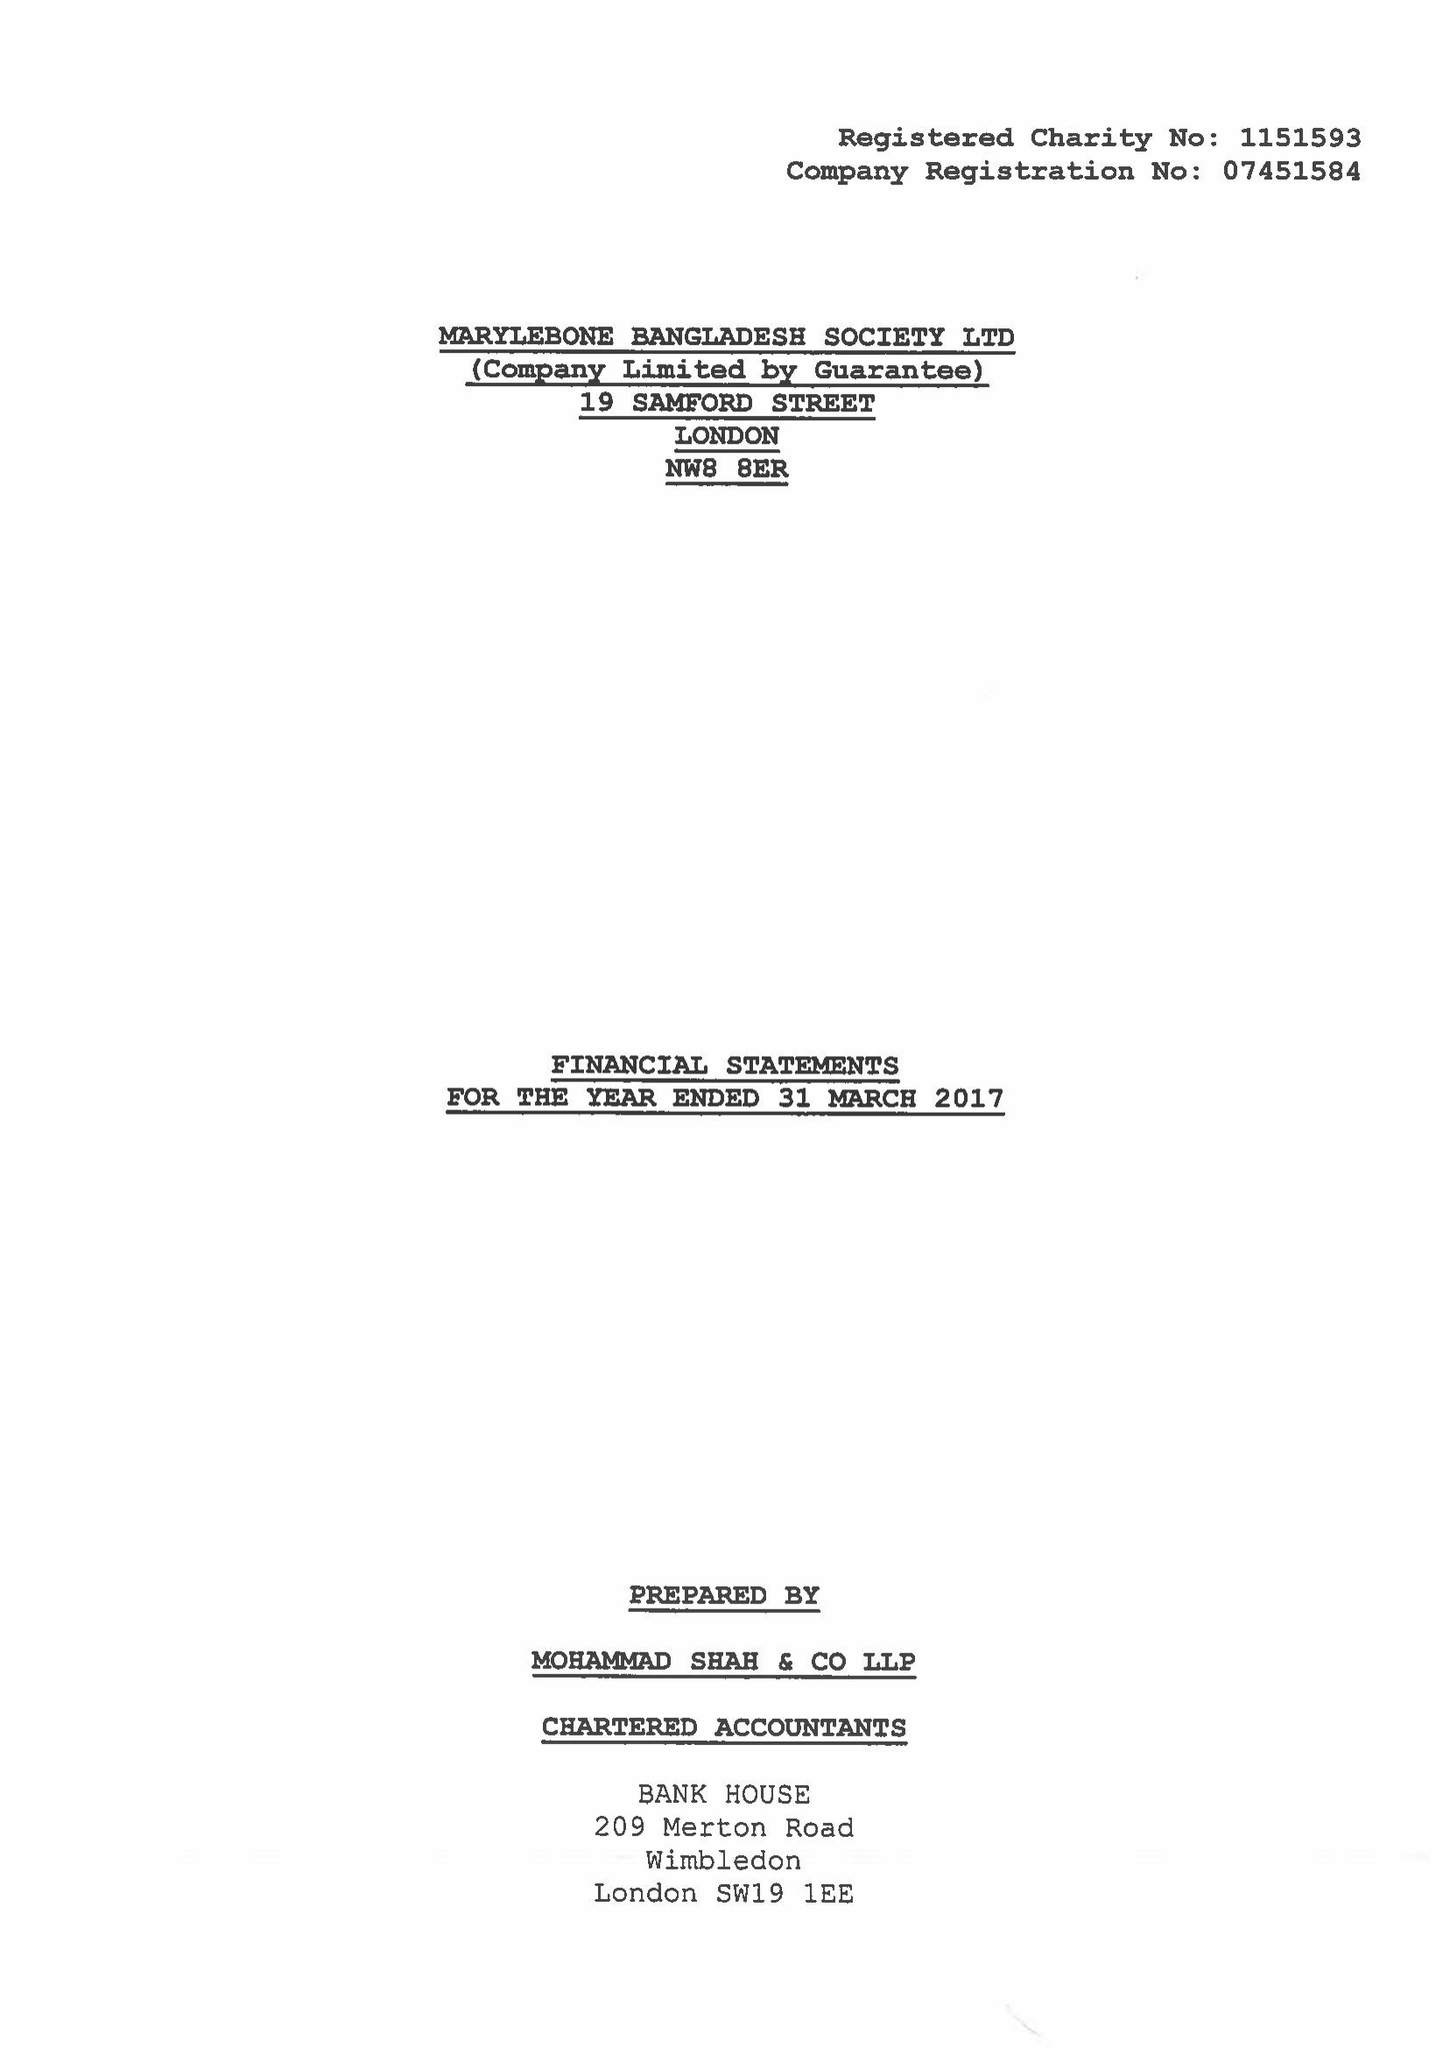What is the value for the address__postcode?
Answer the question using a single word or phrase. NW8 8ER 